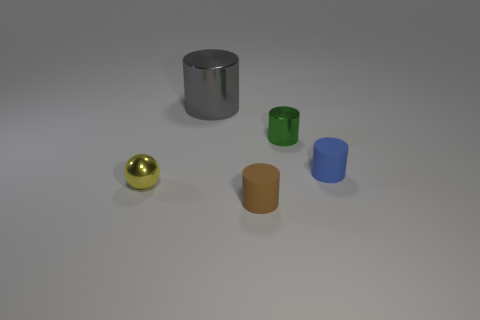Is there anything else that is the same size as the gray cylinder?
Your response must be concise. No. There is a metal thing right of the large cylinder; does it have the same size as the rubber cylinder that is on the left side of the blue thing?
Your answer should be very brief. Yes. What number of things are either tiny things that are left of the brown object or tiny green rubber cylinders?
Provide a short and direct response. 1. What is the material of the gray cylinder?
Keep it short and to the point. Metal. Does the brown object have the same size as the gray cylinder?
Your response must be concise. No. What number of blocks are large objects or small brown objects?
Ensure brevity in your answer.  0. The small thing on the left side of the rubber cylinder that is to the left of the blue cylinder is what color?
Provide a succinct answer. Yellow. Are there fewer brown rubber cylinders on the left side of the green metallic thing than large cylinders on the right side of the big cylinder?
Your response must be concise. No. There is a yellow thing; does it have the same size as the metallic cylinder that is right of the gray shiny cylinder?
Give a very brief answer. Yes. What shape is the metal thing that is to the left of the small green shiny object and right of the yellow ball?
Give a very brief answer. Cylinder. 